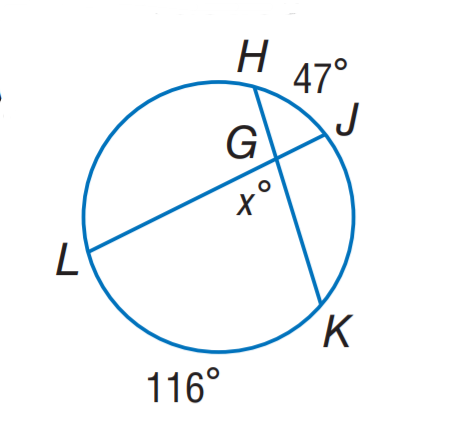Question: Find x.
Choices:
A. 47
B. 58
C. 81.5
D. 94
Answer with the letter. Answer: C 